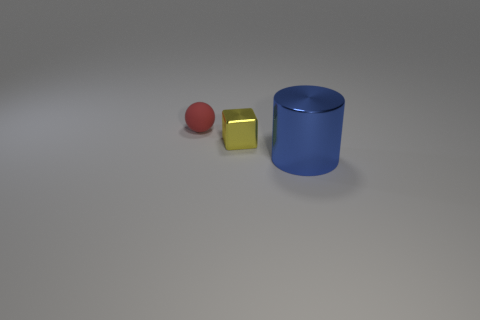Is the size of the red object the same as the metal thing that is left of the blue cylinder?
Your answer should be very brief. Yes. What is the color of the object that is in front of the red matte ball and on the left side of the shiny cylinder?
Offer a terse response. Yellow. Is the number of tiny yellow metallic objects that are left of the small yellow object greater than the number of tiny yellow shiny objects that are right of the large thing?
Keep it short and to the point. No. There is a yellow block that is made of the same material as the large blue object; what size is it?
Make the answer very short. Small. There is a small object to the right of the rubber sphere; what number of shiny objects are in front of it?
Your answer should be very brief. 1. Are there any other things that have the same shape as the big thing?
Give a very brief answer. No. There is a thing that is on the right side of the metallic thing behind the large blue metal object; what color is it?
Make the answer very short. Blue. Is the number of red metallic blocks greater than the number of rubber things?
Your answer should be compact. No. How many blue cylinders are the same size as the yellow cube?
Provide a short and direct response. 0. Are the sphere and the tiny thing right of the tiny red matte sphere made of the same material?
Provide a succinct answer. No. 